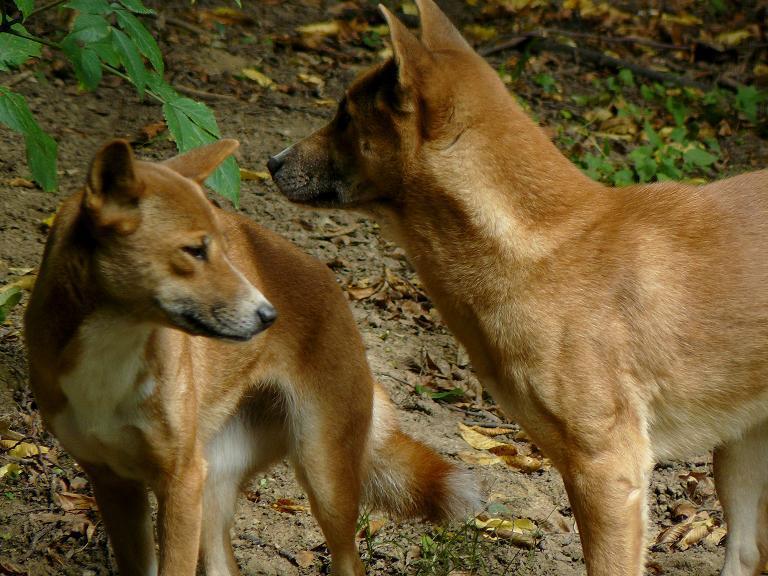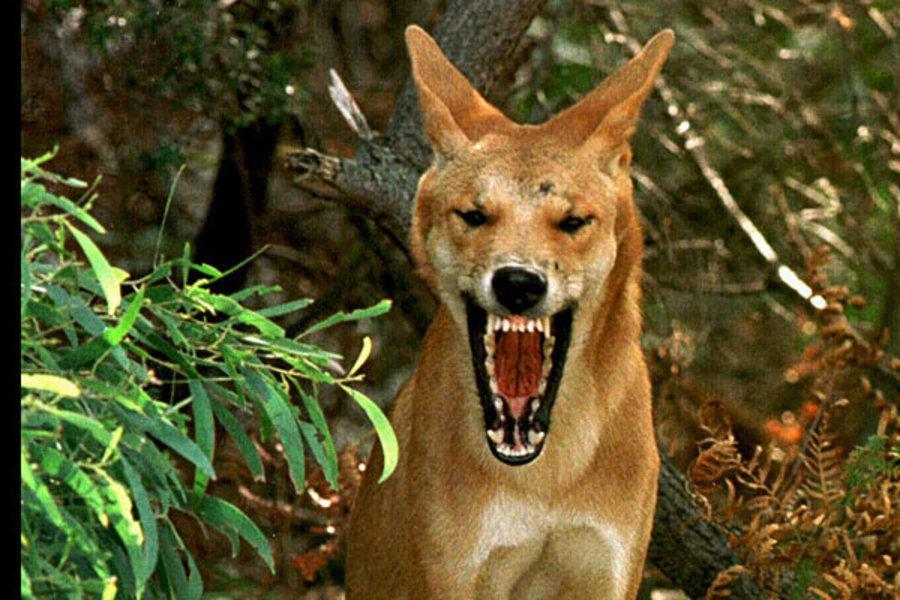The first image is the image on the left, the second image is the image on the right. For the images shown, is this caption "The dog in the image on the left is lying with its mouth open." true? Answer yes or no. No. The first image is the image on the left, the second image is the image on the right. Assess this claim about the two images: "An image shows one leftward-gazing wild dog standing in tall grass.". Correct or not? Answer yes or no. No. 